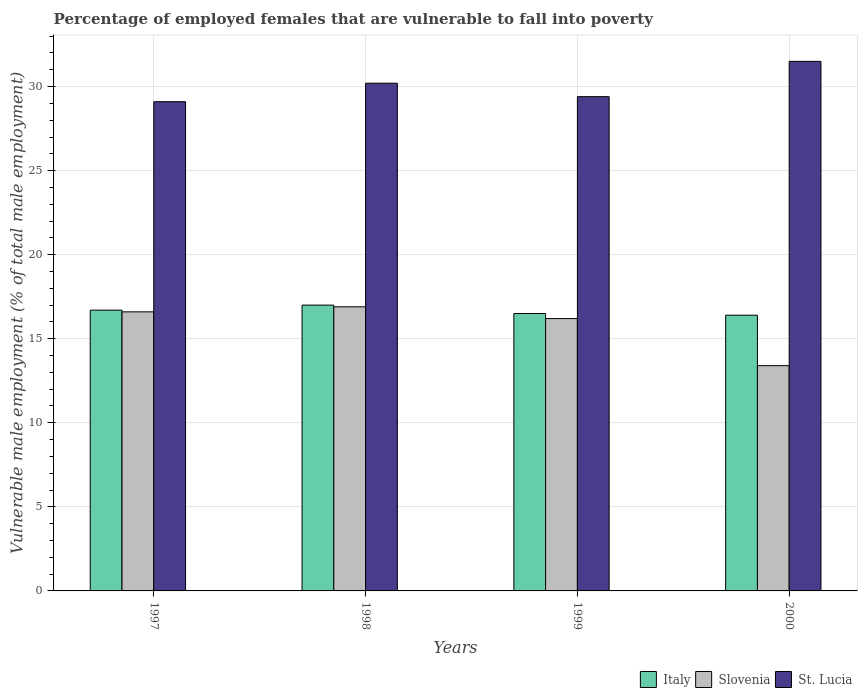How many different coloured bars are there?
Offer a terse response. 3. How many groups of bars are there?
Provide a short and direct response. 4. Are the number of bars on each tick of the X-axis equal?
Your response must be concise. Yes. In how many cases, is the number of bars for a given year not equal to the number of legend labels?
Make the answer very short. 0. What is the percentage of employed females who are vulnerable to fall into poverty in St. Lucia in 1999?
Provide a short and direct response. 29.4. Across all years, what is the maximum percentage of employed females who are vulnerable to fall into poverty in St. Lucia?
Your answer should be very brief. 31.5. Across all years, what is the minimum percentage of employed females who are vulnerable to fall into poverty in Italy?
Provide a short and direct response. 16.4. In which year was the percentage of employed females who are vulnerable to fall into poverty in Italy maximum?
Give a very brief answer. 1998. In which year was the percentage of employed females who are vulnerable to fall into poverty in Slovenia minimum?
Your answer should be compact. 2000. What is the total percentage of employed females who are vulnerable to fall into poverty in Italy in the graph?
Your answer should be very brief. 66.6. What is the difference between the percentage of employed females who are vulnerable to fall into poverty in St. Lucia in 1999 and that in 2000?
Ensure brevity in your answer.  -2.1. What is the difference between the percentage of employed females who are vulnerable to fall into poverty in St. Lucia in 1997 and the percentage of employed females who are vulnerable to fall into poverty in Italy in 1999?
Ensure brevity in your answer.  12.6. What is the average percentage of employed females who are vulnerable to fall into poverty in Italy per year?
Ensure brevity in your answer.  16.65. In the year 1999, what is the difference between the percentage of employed females who are vulnerable to fall into poverty in Slovenia and percentage of employed females who are vulnerable to fall into poverty in St. Lucia?
Provide a short and direct response. -13.2. What is the ratio of the percentage of employed females who are vulnerable to fall into poverty in Italy in 1997 to that in 1999?
Provide a short and direct response. 1.01. What is the difference between the highest and the second highest percentage of employed females who are vulnerable to fall into poverty in St. Lucia?
Ensure brevity in your answer.  1.3. What is the difference between the highest and the lowest percentage of employed females who are vulnerable to fall into poverty in Italy?
Ensure brevity in your answer.  0.6. Is the sum of the percentage of employed females who are vulnerable to fall into poverty in St. Lucia in 1997 and 1999 greater than the maximum percentage of employed females who are vulnerable to fall into poverty in Italy across all years?
Your answer should be compact. Yes. What does the 3rd bar from the left in 1997 represents?
Give a very brief answer. St. Lucia. What does the 1st bar from the right in 2000 represents?
Your response must be concise. St. Lucia. Is it the case that in every year, the sum of the percentage of employed females who are vulnerable to fall into poverty in St. Lucia and percentage of employed females who are vulnerable to fall into poverty in Italy is greater than the percentage of employed females who are vulnerable to fall into poverty in Slovenia?
Keep it short and to the point. Yes. What is the difference between two consecutive major ticks on the Y-axis?
Provide a succinct answer. 5. Does the graph contain grids?
Provide a succinct answer. Yes. Where does the legend appear in the graph?
Provide a short and direct response. Bottom right. How are the legend labels stacked?
Give a very brief answer. Horizontal. What is the title of the graph?
Ensure brevity in your answer.  Percentage of employed females that are vulnerable to fall into poverty. What is the label or title of the Y-axis?
Make the answer very short. Vulnerable male employment (% of total male employment). What is the Vulnerable male employment (% of total male employment) in Italy in 1997?
Offer a terse response. 16.7. What is the Vulnerable male employment (% of total male employment) of Slovenia in 1997?
Your answer should be compact. 16.6. What is the Vulnerable male employment (% of total male employment) of St. Lucia in 1997?
Give a very brief answer. 29.1. What is the Vulnerable male employment (% of total male employment) in Slovenia in 1998?
Ensure brevity in your answer.  16.9. What is the Vulnerable male employment (% of total male employment) in St. Lucia in 1998?
Provide a succinct answer. 30.2. What is the Vulnerable male employment (% of total male employment) in Italy in 1999?
Your answer should be compact. 16.5. What is the Vulnerable male employment (% of total male employment) in Slovenia in 1999?
Provide a short and direct response. 16.2. What is the Vulnerable male employment (% of total male employment) in St. Lucia in 1999?
Keep it short and to the point. 29.4. What is the Vulnerable male employment (% of total male employment) of Italy in 2000?
Offer a terse response. 16.4. What is the Vulnerable male employment (% of total male employment) of Slovenia in 2000?
Offer a very short reply. 13.4. What is the Vulnerable male employment (% of total male employment) of St. Lucia in 2000?
Keep it short and to the point. 31.5. Across all years, what is the maximum Vulnerable male employment (% of total male employment) of Italy?
Provide a short and direct response. 17. Across all years, what is the maximum Vulnerable male employment (% of total male employment) in Slovenia?
Your response must be concise. 16.9. Across all years, what is the maximum Vulnerable male employment (% of total male employment) of St. Lucia?
Ensure brevity in your answer.  31.5. Across all years, what is the minimum Vulnerable male employment (% of total male employment) in Italy?
Provide a succinct answer. 16.4. Across all years, what is the minimum Vulnerable male employment (% of total male employment) of Slovenia?
Give a very brief answer. 13.4. Across all years, what is the minimum Vulnerable male employment (% of total male employment) of St. Lucia?
Your answer should be compact. 29.1. What is the total Vulnerable male employment (% of total male employment) in Italy in the graph?
Make the answer very short. 66.6. What is the total Vulnerable male employment (% of total male employment) in Slovenia in the graph?
Your answer should be compact. 63.1. What is the total Vulnerable male employment (% of total male employment) in St. Lucia in the graph?
Provide a succinct answer. 120.2. What is the difference between the Vulnerable male employment (% of total male employment) in Slovenia in 1997 and that in 1998?
Ensure brevity in your answer.  -0.3. What is the difference between the Vulnerable male employment (% of total male employment) of St. Lucia in 1997 and that in 1998?
Provide a short and direct response. -1.1. What is the difference between the Vulnerable male employment (% of total male employment) in Slovenia in 1997 and that in 1999?
Make the answer very short. 0.4. What is the difference between the Vulnerable male employment (% of total male employment) in Slovenia in 1997 and that in 2000?
Provide a succinct answer. 3.2. What is the difference between the Vulnerable male employment (% of total male employment) of Slovenia in 1998 and that in 1999?
Provide a succinct answer. 0.7. What is the difference between the Vulnerable male employment (% of total male employment) of St. Lucia in 1998 and that in 1999?
Make the answer very short. 0.8. What is the difference between the Vulnerable male employment (% of total male employment) of Slovenia in 1998 and that in 2000?
Provide a short and direct response. 3.5. What is the difference between the Vulnerable male employment (% of total male employment) of Italy in 1999 and that in 2000?
Your response must be concise. 0.1. What is the difference between the Vulnerable male employment (% of total male employment) in Italy in 1997 and the Vulnerable male employment (% of total male employment) in Slovenia in 1998?
Provide a short and direct response. -0.2. What is the difference between the Vulnerable male employment (% of total male employment) in Italy in 1997 and the Vulnerable male employment (% of total male employment) in St. Lucia in 1998?
Provide a succinct answer. -13.5. What is the difference between the Vulnerable male employment (% of total male employment) in Italy in 1997 and the Vulnerable male employment (% of total male employment) in Slovenia in 1999?
Your response must be concise. 0.5. What is the difference between the Vulnerable male employment (% of total male employment) in Italy in 1997 and the Vulnerable male employment (% of total male employment) in St. Lucia in 1999?
Your answer should be very brief. -12.7. What is the difference between the Vulnerable male employment (% of total male employment) of Slovenia in 1997 and the Vulnerable male employment (% of total male employment) of St. Lucia in 1999?
Provide a short and direct response. -12.8. What is the difference between the Vulnerable male employment (% of total male employment) in Italy in 1997 and the Vulnerable male employment (% of total male employment) in Slovenia in 2000?
Keep it short and to the point. 3.3. What is the difference between the Vulnerable male employment (% of total male employment) in Italy in 1997 and the Vulnerable male employment (% of total male employment) in St. Lucia in 2000?
Offer a very short reply. -14.8. What is the difference between the Vulnerable male employment (% of total male employment) in Slovenia in 1997 and the Vulnerable male employment (% of total male employment) in St. Lucia in 2000?
Give a very brief answer. -14.9. What is the difference between the Vulnerable male employment (% of total male employment) in Italy in 1998 and the Vulnerable male employment (% of total male employment) in St. Lucia in 1999?
Give a very brief answer. -12.4. What is the difference between the Vulnerable male employment (% of total male employment) of Slovenia in 1998 and the Vulnerable male employment (% of total male employment) of St. Lucia in 2000?
Offer a very short reply. -14.6. What is the difference between the Vulnerable male employment (% of total male employment) in Slovenia in 1999 and the Vulnerable male employment (% of total male employment) in St. Lucia in 2000?
Offer a very short reply. -15.3. What is the average Vulnerable male employment (% of total male employment) of Italy per year?
Provide a short and direct response. 16.65. What is the average Vulnerable male employment (% of total male employment) of Slovenia per year?
Make the answer very short. 15.78. What is the average Vulnerable male employment (% of total male employment) in St. Lucia per year?
Keep it short and to the point. 30.05. In the year 1997, what is the difference between the Vulnerable male employment (% of total male employment) in Italy and Vulnerable male employment (% of total male employment) in St. Lucia?
Offer a very short reply. -12.4. In the year 1998, what is the difference between the Vulnerable male employment (% of total male employment) in Italy and Vulnerable male employment (% of total male employment) in St. Lucia?
Provide a short and direct response. -13.2. In the year 1999, what is the difference between the Vulnerable male employment (% of total male employment) in Italy and Vulnerable male employment (% of total male employment) in St. Lucia?
Make the answer very short. -12.9. In the year 1999, what is the difference between the Vulnerable male employment (% of total male employment) of Slovenia and Vulnerable male employment (% of total male employment) of St. Lucia?
Offer a terse response. -13.2. In the year 2000, what is the difference between the Vulnerable male employment (% of total male employment) of Italy and Vulnerable male employment (% of total male employment) of Slovenia?
Give a very brief answer. 3. In the year 2000, what is the difference between the Vulnerable male employment (% of total male employment) of Italy and Vulnerable male employment (% of total male employment) of St. Lucia?
Give a very brief answer. -15.1. In the year 2000, what is the difference between the Vulnerable male employment (% of total male employment) in Slovenia and Vulnerable male employment (% of total male employment) in St. Lucia?
Your answer should be very brief. -18.1. What is the ratio of the Vulnerable male employment (% of total male employment) of Italy in 1997 to that in 1998?
Provide a short and direct response. 0.98. What is the ratio of the Vulnerable male employment (% of total male employment) of Slovenia in 1997 to that in 1998?
Provide a short and direct response. 0.98. What is the ratio of the Vulnerable male employment (% of total male employment) in St. Lucia in 1997 to that in 1998?
Your answer should be compact. 0.96. What is the ratio of the Vulnerable male employment (% of total male employment) of Italy in 1997 to that in 1999?
Give a very brief answer. 1.01. What is the ratio of the Vulnerable male employment (% of total male employment) of Slovenia in 1997 to that in 1999?
Provide a short and direct response. 1.02. What is the ratio of the Vulnerable male employment (% of total male employment) in St. Lucia in 1997 to that in 1999?
Keep it short and to the point. 0.99. What is the ratio of the Vulnerable male employment (% of total male employment) in Italy in 1997 to that in 2000?
Offer a terse response. 1.02. What is the ratio of the Vulnerable male employment (% of total male employment) in Slovenia in 1997 to that in 2000?
Make the answer very short. 1.24. What is the ratio of the Vulnerable male employment (% of total male employment) of St. Lucia in 1997 to that in 2000?
Your response must be concise. 0.92. What is the ratio of the Vulnerable male employment (% of total male employment) of Italy in 1998 to that in 1999?
Your answer should be very brief. 1.03. What is the ratio of the Vulnerable male employment (% of total male employment) of Slovenia in 1998 to that in 1999?
Offer a very short reply. 1.04. What is the ratio of the Vulnerable male employment (% of total male employment) in St. Lucia in 1998 to that in 1999?
Provide a succinct answer. 1.03. What is the ratio of the Vulnerable male employment (% of total male employment) of Italy in 1998 to that in 2000?
Give a very brief answer. 1.04. What is the ratio of the Vulnerable male employment (% of total male employment) of Slovenia in 1998 to that in 2000?
Your answer should be compact. 1.26. What is the ratio of the Vulnerable male employment (% of total male employment) of St. Lucia in 1998 to that in 2000?
Your response must be concise. 0.96. What is the ratio of the Vulnerable male employment (% of total male employment) of Slovenia in 1999 to that in 2000?
Provide a short and direct response. 1.21. What is the ratio of the Vulnerable male employment (% of total male employment) of St. Lucia in 1999 to that in 2000?
Your answer should be very brief. 0.93. What is the difference between the highest and the second highest Vulnerable male employment (% of total male employment) in St. Lucia?
Give a very brief answer. 1.3. What is the difference between the highest and the lowest Vulnerable male employment (% of total male employment) of Italy?
Your answer should be very brief. 0.6. What is the difference between the highest and the lowest Vulnerable male employment (% of total male employment) of Slovenia?
Your answer should be very brief. 3.5. What is the difference between the highest and the lowest Vulnerable male employment (% of total male employment) in St. Lucia?
Your answer should be very brief. 2.4. 